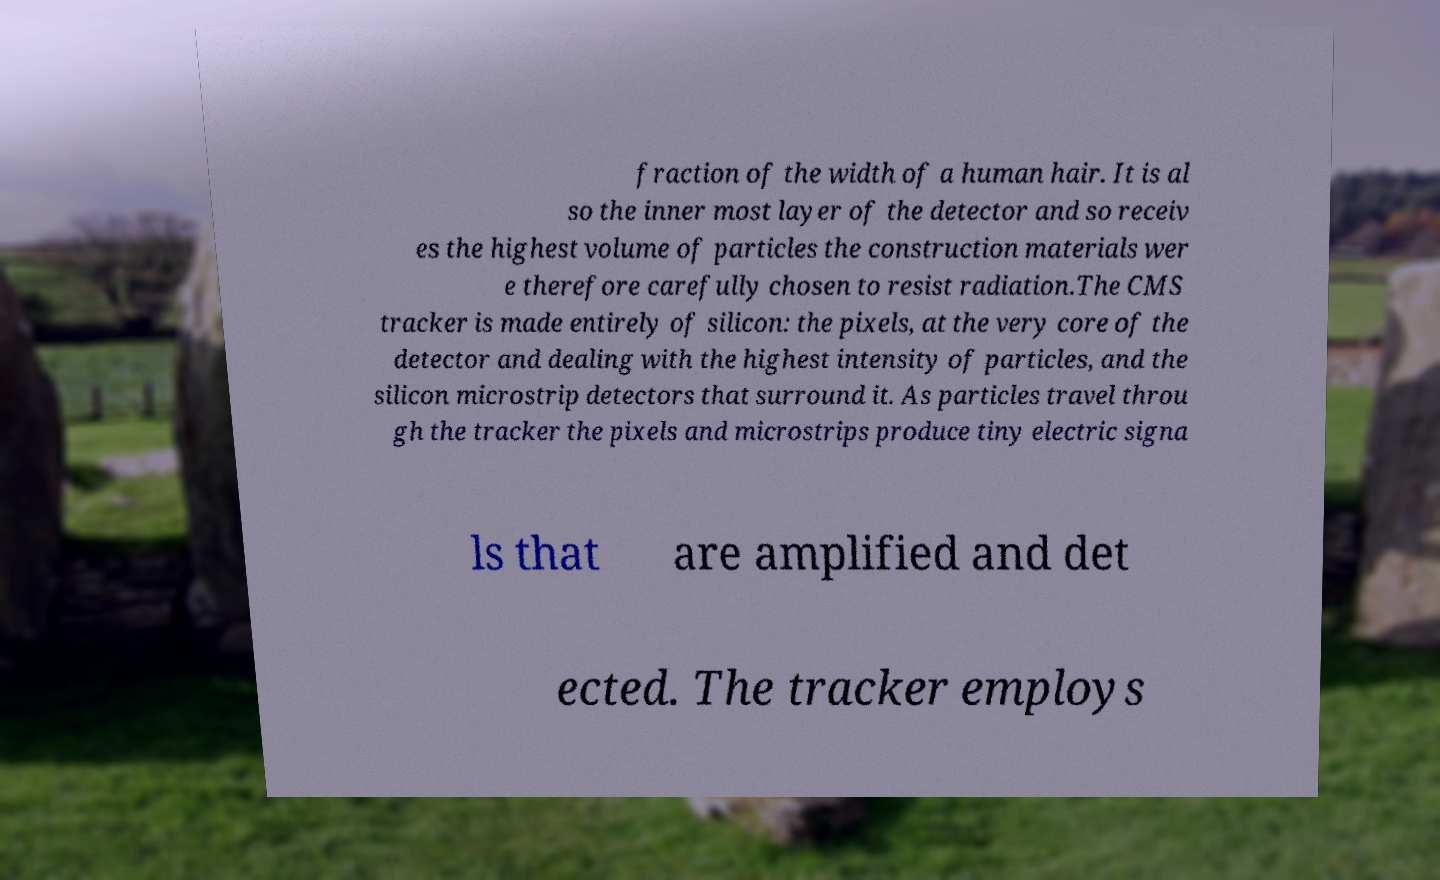Could you assist in decoding the text presented in this image and type it out clearly? fraction of the width of a human hair. It is al so the inner most layer of the detector and so receiv es the highest volume of particles the construction materials wer e therefore carefully chosen to resist radiation.The CMS tracker is made entirely of silicon: the pixels, at the very core of the detector and dealing with the highest intensity of particles, and the silicon microstrip detectors that surround it. As particles travel throu gh the tracker the pixels and microstrips produce tiny electric signa ls that are amplified and det ected. The tracker employs 